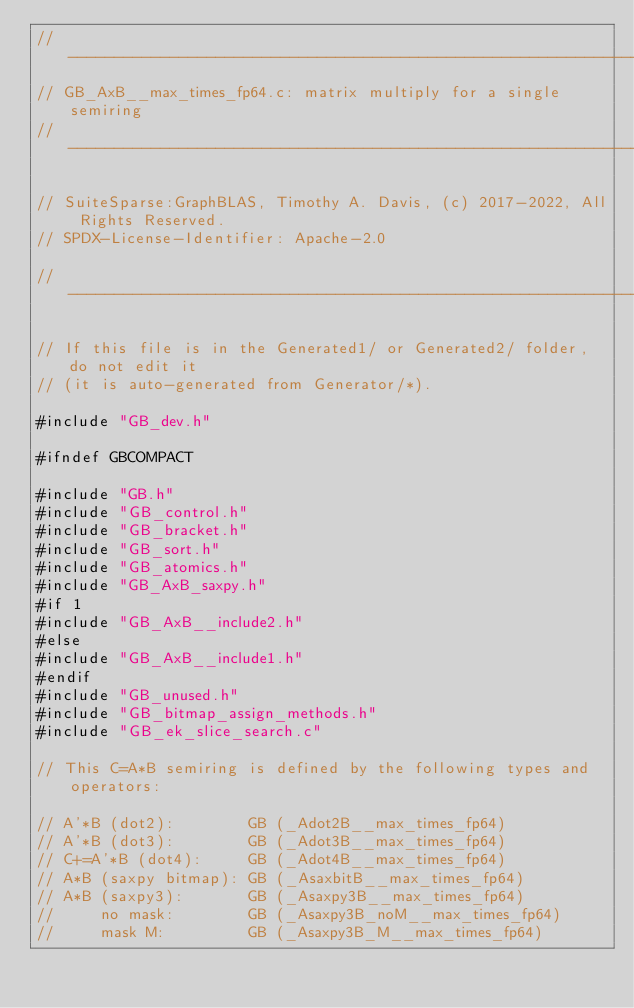<code> <loc_0><loc_0><loc_500><loc_500><_C_>//------------------------------------------------------------------------------
// GB_AxB__max_times_fp64.c: matrix multiply for a single semiring
//------------------------------------------------------------------------------

// SuiteSparse:GraphBLAS, Timothy A. Davis, (c) 2017-2022, All Rights Reserved.
// SPDX-License-Identifier: Apache-2.0

//------------------------------------------------------------------------------

// If this file is in the Generated1/ or Generated2/ folder, do not edit it
// (it is auto-generated from Generator/*).

#include "GB_dev.h"

#ifndef GBCOMPACT

#include "GB.h"
#include "GB_control.h"
#include "GB_bracket.h"
#include "GB_sort.h"
#include "GB_atomics.h"
#include "GB_AxB_saxpy.h"
#if 1
#include "GB_AxB__include2.h"
#else
#include "GB_AxB__include1.h"
#endif
#include "GB_unused.h"
#include "GB_bitmap_assign_methods.h"
#include "GB_ek_slice_search.c"

// This C=A*B semiring is defined by the following types and operators:

// A'*B (dot2):        GB (_Adot2B__max_times_fp64)
// A'*B (dot3):        GB (_Adot3B__max_times_fp64)
// C+=A'*B (dot4):     GB (_Adot4B__max_times_fp64)
// A*B (saxpy bitmap): GB (_AsaxbitB__max_times_fp64)
// A*B (saxpy3):       GB (_Asaxpy3B__max_times_fp64)
//     no mask:        GB (_Asaxpy3B_noM__max_times_fp64)
//     mask M:         GB (_Asaxpy3B_M__max_times_fp64)</code> 